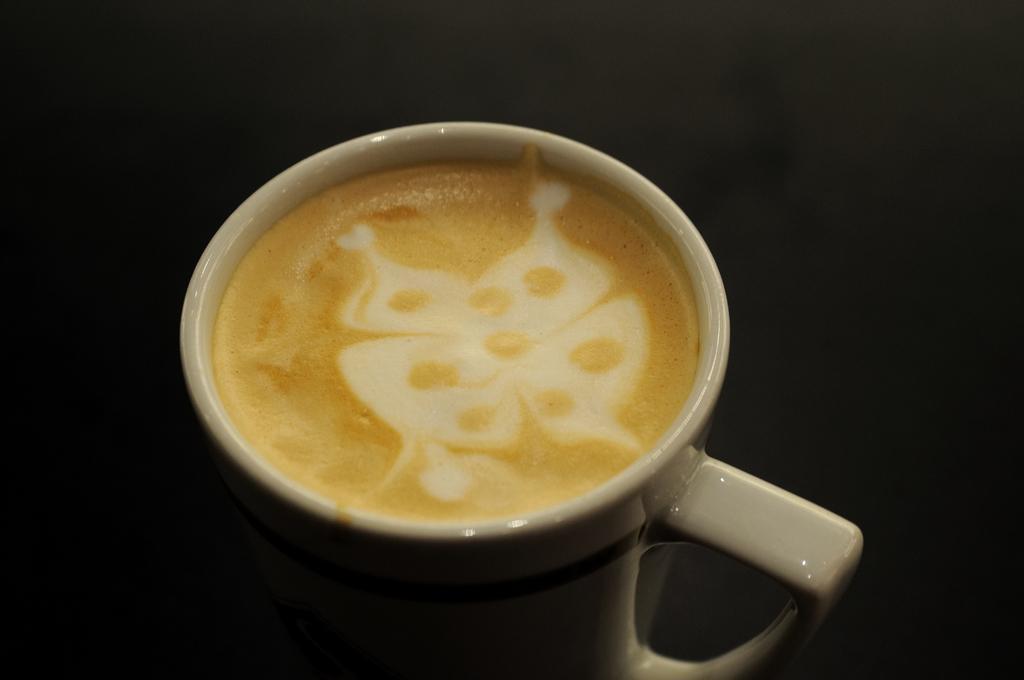Please provide a concise description of this image. In the foreground of this picture, there is a office in a cup on the surface. 